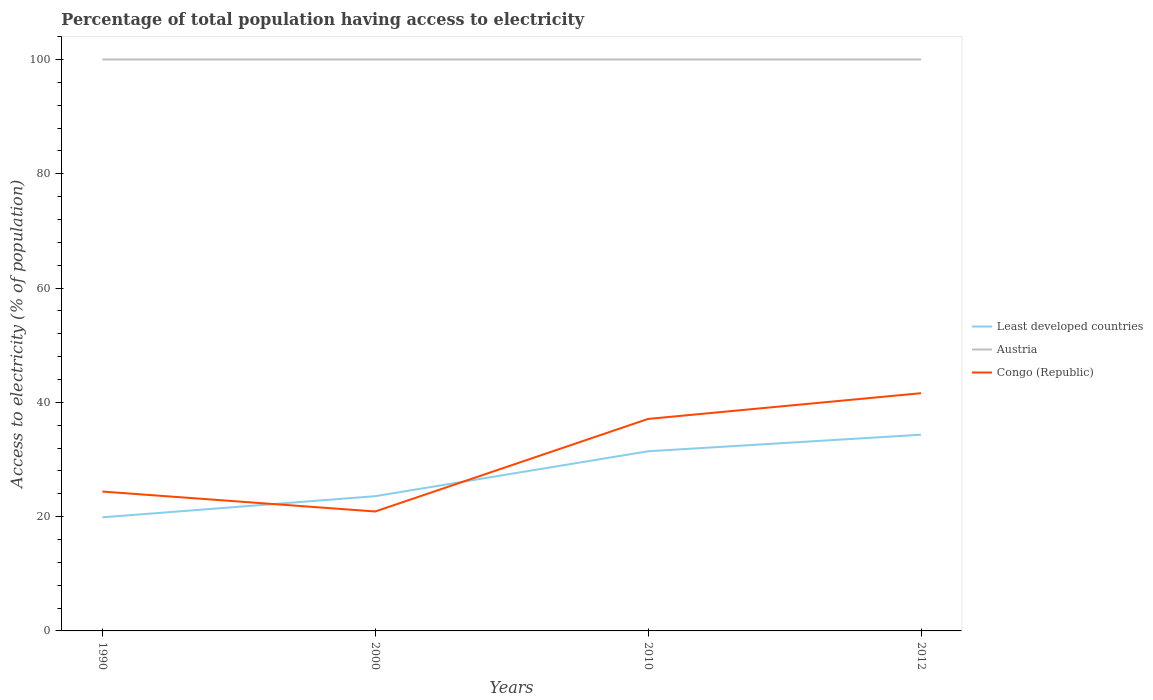How many different coloured lines are there?
Provide a succinct answer. 3. Is the number of lines equal to the number of legend labels?
Your answer should be very brief. Yes. Across all years, what is the maximum percentage of population that have access to electricity in Congo (Republic)?
Ensure brevity in your answer.  20.9. What is the total percentage of population that have access to electricity in Least developed countries in the graph?
Your response must be concise. -14.46. What is the difference between the highest and the second highest percentage of population that have access to electricity in Congo (Republic)?
Your answer should be compact. 20.7. How many lines are there?
Offer a terse response. 3. How many years are there in the graph?
Your answer should be compact. 4. What is the difference between two consecutive major ticks on the Y-axis?
Provide a succinct answer. 20. Does the graph contain any zero values?
Keep it short and to the point. No. Does the graph contain grids?
Provide a short and direct response. No. Where does the legend appear in the graph?
Your answer should be compact. Center right. How many legend labels are there?
Offer a very short reply. 3. How are the legend labels stacked?
Your answer should be compact. Vertical. What is the title of the graph?
Give a very brief answer. Percentage of total population having access to electricity. What is the label or title of the X-axis?
Keep it short and to the point. Years. What is the label or title of the Y-axis?
Offer a terse response. Access to electricity (% of population). What is the Access to electricity (% of population) of Least developed countries in 1990?
Offer a terse response. 19.88. What is the Access to electricity (% of population) in Congo (Republic) in 1990?
Your answer should be very brief. 24.39. What is the Access to electricity (% of population) in Least developed countries in 2000?
Make the answer very short. 23.58. What is the Access to electricity (% of population) in Austria in 2000?
Keep it short and to the point. 100. What is the Access to electricity (% of population) in Congo (Republic) in 2000?
Provide a succinct answer. 20.9. What is the Access to electricity (% of population) of Least developed countries in 2010?
Provide a short and direct response. 31.44. What is the Access to electricity (% of population) in Congo (Republic) in 2010?
Make the answer very short. 37.1. What is the Access to electricity (% of population) of Least developed countries in 2012?
Provide a succinct answer. 34.34. What is the Access to electricity (% of population) in Austria in 2012?
Make the answer very short. 100. What is the Access to electricity (% of population) of Congo (Republic) in 2012?
Keep it short and to the point. 41.6. Across all years, what is the maximum Access to electricity (% of population) in Least developed countries?
Give a very brief answer. 34.34. Across all years, what is the maximum Access to electricity (% of population) in Congo (Republic)?
Give a very brief answer. 41.6. Across all years, what is the minimum Access to electricity (% of population) of Least developed countries?
Make the answer very short. 19.88. Across all years, what is the minimum Access to electricity (% of population) of Congo (Republic)?
Provide a short and direct response. 20.9. What is the total Access to electricity (% of population) in Least developed countries in the graph?
Your response must be concise. 109.23. What is the total Access to electricity (% of population) in Austria in the graph?
Your answer should be compact. 400. What is the total Access to electricity (% of population) in Congo (Republic) in the graph?
Provide a succinct answer. 123.99. What is the difference between the Access to electricity (% of population) of Least developed countries in 1990 and that in 2000?
Make the answer very short. -3.7. What is the difference between the Access to electricity (% of population) in Austria in 1990 and that in 2000?
Offer a very short reply. 0. What is the difference between the Access to electricity (% of population) in Congo (Republic) in 1990 and that in 2000?
Provide a short and direct response. 3.49. What is the difference between the Access to electricity (% of population) in Least developed countries in 1990 and that in 2010?
Keep it short and to the point. -11.56. What is the difference between the Access to electricity (% of population) of Austria in 1990 and that in 2010?
Keep it short and to the point. 0. What is the difference between the Access to electricity (% of population) in Congo (Republic) in 1990 and that in 2010?
Offer a very short reply. -12.71. What is the difference between the Access to electricity (% of population) in Least developed countries in 1990 and that in 2012?
Keep it short and to the point. -14.46. What is the difference between the Access to electricity (% of population) of Congo (Republic) in 1990 and that in 2012?
Provide a succinct answer. -17.21. What is the difference between the Access to electricity (% of population) of Least developed countries in 2000 and that in 2010?
Keep it short and to the point. -7.86. What is the difference between the Access to electricity (% of population) in Austria in 2000 and that in 2010?
Keep it short and to the point. 0. What is the difference between the Access to electricity (% of population) of Congo (Republic) in 2000 and that in 2010?
Make the answer very short. -16.2. What is the difference between the Access to electricity (% of population) in Least developed countries in 2000 and that in 2012?
Your response must be concise. -10.76. What is the difference between the Access to electricity (% of population) in Congo (Republic) in 2000 and that in 2012?
Make the answer very short. -20.7. What is the difference between the Access to electricity (% of population) in Least developed countries in 2010 and that in 2012?
Offer a terse response. -2.9. What is the difference between the Access to electricity (% of population) in Austria in 2010 and that in 2012?
Your response must be concise. 0. What is the difference between the Access to electricity (% of population) of Congo (Republic) in 2010 and that in 2012?
Make the answer very short. -4.5. What is the difference between the Access to electricity (% of population) in Least developed countries in 1990 and the Access to electricity (% of population) in Austria in 2000?
Provide a short and direct response. -80.12. What is the difference between the Access to electricity (% of population) in Least developed countries in 1990 and the Access to electricity (% of population) in Congo (Republic) in 2000?
Your answer should be very brief. -1.02. What is the difference between the Access to electricity (% of population) in Austria in 1990 and the Access to electricity (% of population) in Congo (Republic) in 2000?
Ensure brevity in your answer.  79.1. What is the difference between the Access to electricity (% of population) in Least developed countries in 1990 and the Access to electricity (% of population) in Austria in 2010?
Your answer should be very brief. -80.12. What is the difference between the Access to electricity (% of population) of Least developed countries in 1990 and the Access to electricity (% of population) of Congo (Republic) in 2010?
Your answer should be compact. -17.22. What is the difference between the Access to electricity (% of population) in Austria in 1990 and the Access to electricity (% of population) in Congo (Republic) in 2010?
Make the answer very short. 62.9. What is the difference between the Access to electricity (% of population) in Least developed countries in 1990 and the Access to electricity (% of population) in Austria in 2012?
Provide a succinct answer. -80.12. What is the difference between the Access to electricity (% of population) of Least developed countries in 1990 and the Access to electricity (% of population) of Congo (Republic) in 2012?
Make the answer very short. -21.72. What is the difference between the Access to electricity (% of population) of Austria in 1990 and the Access to electricity (% of population) of Congo (Republic) in 2012?
Offer a terse response. 58.4. What is the difference between the Access to electricity (% of population) in Least developed countries in 2000 and the Access to electricity (% of population) in Austria in 2010?
Your answer should be very brief. -76.42. What is the difference between the Access to electricity (% of population) in Least developed countries in 2000 and the Access to electricity (% of population) in Congo (Republic) in 2010?
Make the answer very short. -13.52. What is the difference between the Access to electricity (% of population) in Austria in 2000 and the Access to electricity (% of population) in Congo (Republic) in 2010?
Your answer should be very brief. 62.9. What is the difference between the Access to electricity (% of population) of Least developed countries in 2000 and the Access to electricity (% of population) of Austria in 2012?
Give a very brief answer. -76.42. What is the difference between the Access to electricity (% of population) of Least developed countries in 2000 and the Access to electricity (% of population) of Congo (Republic) in 2012?
Your response must be concise. -18.02. What is the difference between the Access to electricity (% of population) of Austria in 2000 and the Access to electricity (% of population) of Congo (Republic) in 2012?
Provide a succinct answer. 58.4. What is the difference between the Access to electricity (% of population) in Least developed countries in 2010 and the Access to electricity (% of population) in Austria in 2012?
Your response must be concise. -68.56. What is the difference between the Access to electricity (% of population) of Least developed countries in 2010 and the Access to electricity (% of population) of Congo (Republic) in 2012?
Give a very brief answer. -10.16. What is the difference between the Access to electricity (% of population) in Austria in 2010 and the Access to electricity (% of population) in Congo (Republic) in 2012?
Offer a very short reply. 58.4. What is the average Access to electricity (% of population) of Least developed countries per year?
Your answer should be compact. 27.31. What is the average Access to electricity (% of population) of Congo (Republic) per year?
Provide a short and direct response. 31. In the year 1990, what is the difference between the Access to electricity (% of population) in Least developed countries and Access to electricity (% of population) in Austria?
Give a very brief answer. -80.12. In the year 1990, what is the difference between the Access to electricity (% of population) of Least developed countries and Access to electricity (% of population) of Congo (Republic)?
Provide a succinct answer. -4.51. In the year 1990, what is the difference between the Access to electricity (% of population) of Austria and Access to electricity (% of population) of Congo (Republic)?
Offer a terse response. 75.61. In the year 2000, what is the difference between the Access to electricity (% of population) of Least developed countries and Access to electricity (% of population) of Austria?
Your answer should be compact. -76.42. In the year 2000, what is the difference between the Access to electricity (% of population) of Least developed countries and Access to electricity (% of population) of Congo (Republic)?
Your answer should be compact. 2.68. In the year 2000, what is the difference between the Access to electricity (% of population) in Austria and Access to electricity (% of population) in Congo (Republic)?
Keep it short and to the point. 79.1. In the year 2010, what is the difference between the Access to electricity (% of population) of Least developed countries and Access to electricity (% of population) of Austria?
Your answer should be very brief. -68.56. In the year 2010, what is the difference between the Access to electricity (% of population) in Least developed countries and Access to electricity (% of population) in Congo (Republic)?
Offer a terse response. -5.66. In the year 2010, what is the difference between the Access to electricity (% of population) of Austria and Access to electricity (% of population) of Congo (Republic)?
Your response must be concise. 62.9. In the year 2012, what is the difference between the Access to electricity (% of population) of Least developed countries and Access to electricity (% of population) of Austria?
Offer a very short reply. -65.66. In the year 2012, what is the difference between the Access to electricity (% of population) of Least developed countries and Access to electricity (% of population) of Congo (Republic)?
Keep it short and to the point. -7.26. In the year 2012, what is the difference between the Access to electricity (% of population) in Austria and Access to electricity (% of population) in Congo (Republic)?
Keep it short and to the point. 58.4. What is the ratio of the Access to electricity (% of population) in Least developed countries in 1990 to that in 2000?
Your answer should be very brief. 0.84. What is the ratio of the Access to electricity (% of population) of Congo (Republic) in 1990 to that in 2000?
Offer a very short reply. 1.17. What is the ratio of the Access to electricity (% of population) of Least developed countries in 1990 to that in 2010?
Keep it short and to the point. 0.63. What is the ratio of the Access to electricity (% of population) in Congo (Republic) in 1990 to that in 2010?
Make the answer very short. 0.66. What is the ratio of the Access to electricity (% of population) of Least developed countries in 1990 to that in 2012?
Your answer should be compact. 0.58. What is the ratio of the Access to electricity (% of population) of Congo (Republic) in 1990 to that in 2012?
Offer a terse response. 0.59. What is the ratio of the Access to electricity (% of population) in Least developed countries in 2000 to that in 2010?
Offer a terse response. 0.75. What is the ratio of the Access to electricity (% of population) in Austria in 2000 to that in 2010?
Offer a very short reply. 1. What is the ratio of the Access to electricity (% of population) of Congo (Republic) in 2000 to that in 2010?
Your response must be concise. 0.56. What is the ratio of the Access to electricity (% of population) in Least developed countries in 2000 to that in 2012?
Provide a short and direct response. 0.69. What is the ratio of the Access to electricity (% of population) in Austria in 2000 to that in 2012?
Give a very brief answer. 1. What is the ratio of the Access to electricity (% of population) in Congo (Republic) in 2000 to that in 2012?
Ensure brevity in your answer.  0.5. What is the ratio of the Access to electricity (% of population) of Least developed countries in 2010 to that in 2012?
Keep it short and to the point. 0.92. What is the ratio of the Access to electricity (% of population) in Congo (Republic) in 2010 to that in 2012?
Offer a terse response. 0.89. What is the difference between the highest and the second highest Access to electricity (% of population) of Least developed countries?
Make the answer very short. 2.9. What is the difference between the highest and the second highest Access to electricity (% of population) in Congo (Republic)?
Your answer should be compact. 4.5. What is the difference between the highest and the lowest Access to electricity (% of population) of Least developed countries?
Your answer should be compact. 14.46. What is the difference between the highest and the lowest Access to electricity (% of population) in Congo (Republic)?
Keep it short and to the point. 20.7. 